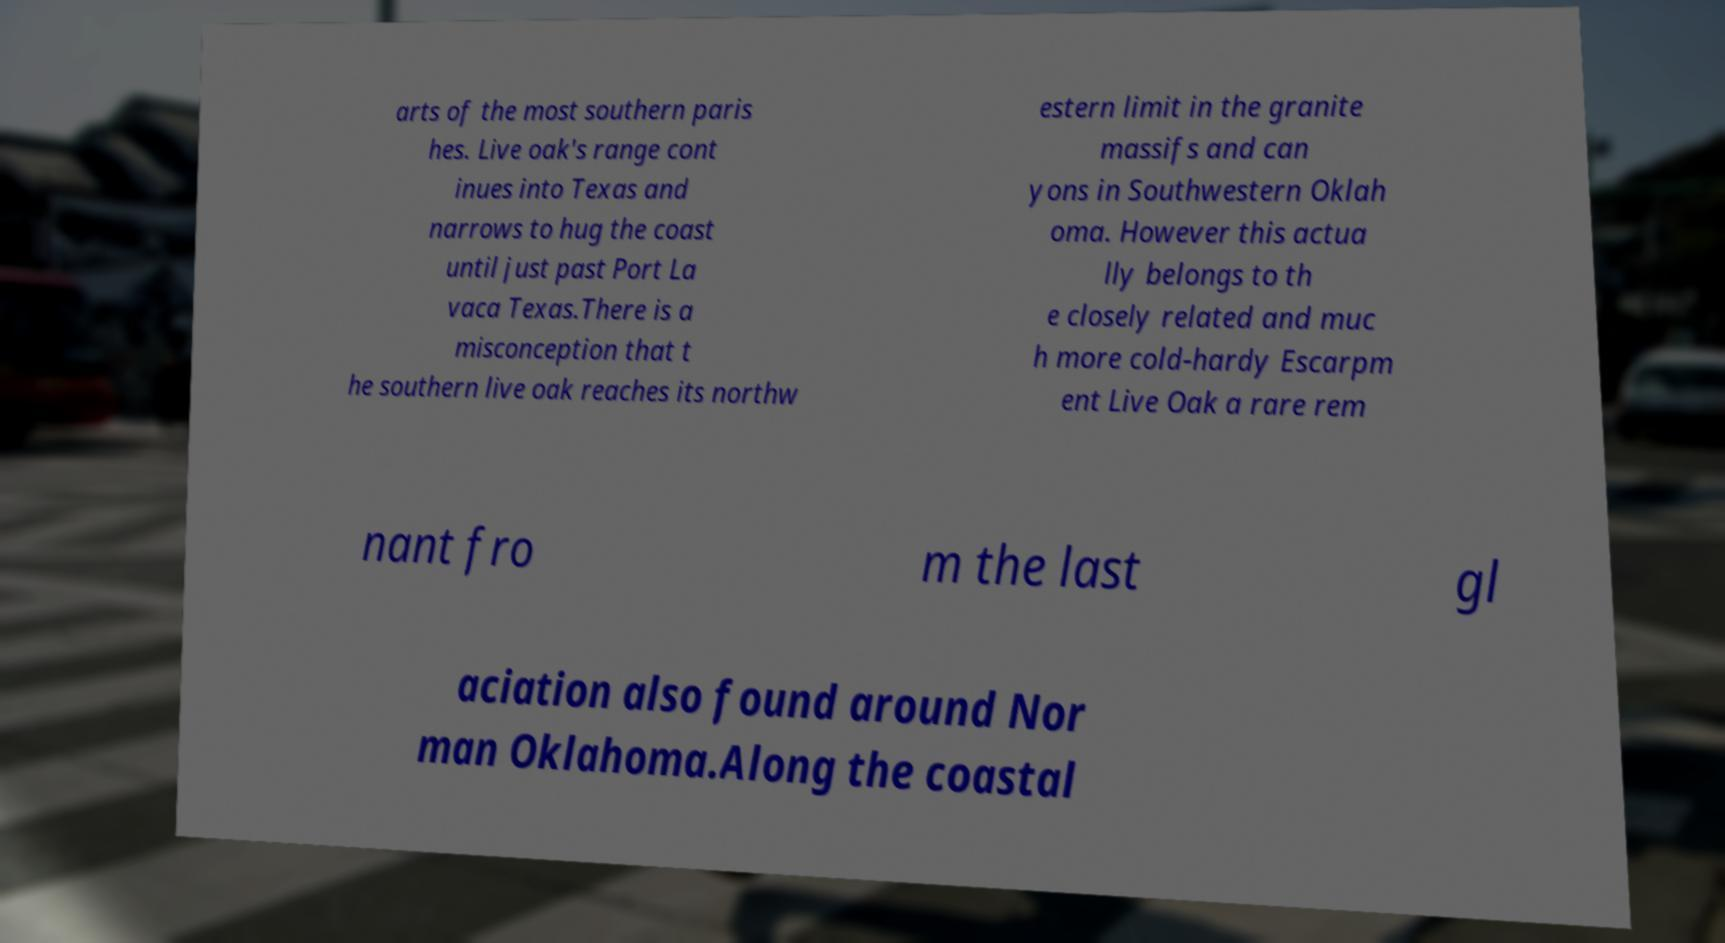I need the written content from this picture converted into text. Can you do that? arts of the most southern paris hes. Live oak's range cont inues into Texas and narrows to hug the coast until just past Port La vaca Texas.There is a misconception that t he southern live oak reaches its northw estern limit in the granite massifs and can yons in Southwestern Oklah oma. However this actua lly belongs to th e closely related and muc h more cold-hardy Escarpm ent Live Oak a rare rem nant fro m the last gl aciation also found around Nor man Oklahoma.Along the coastal 